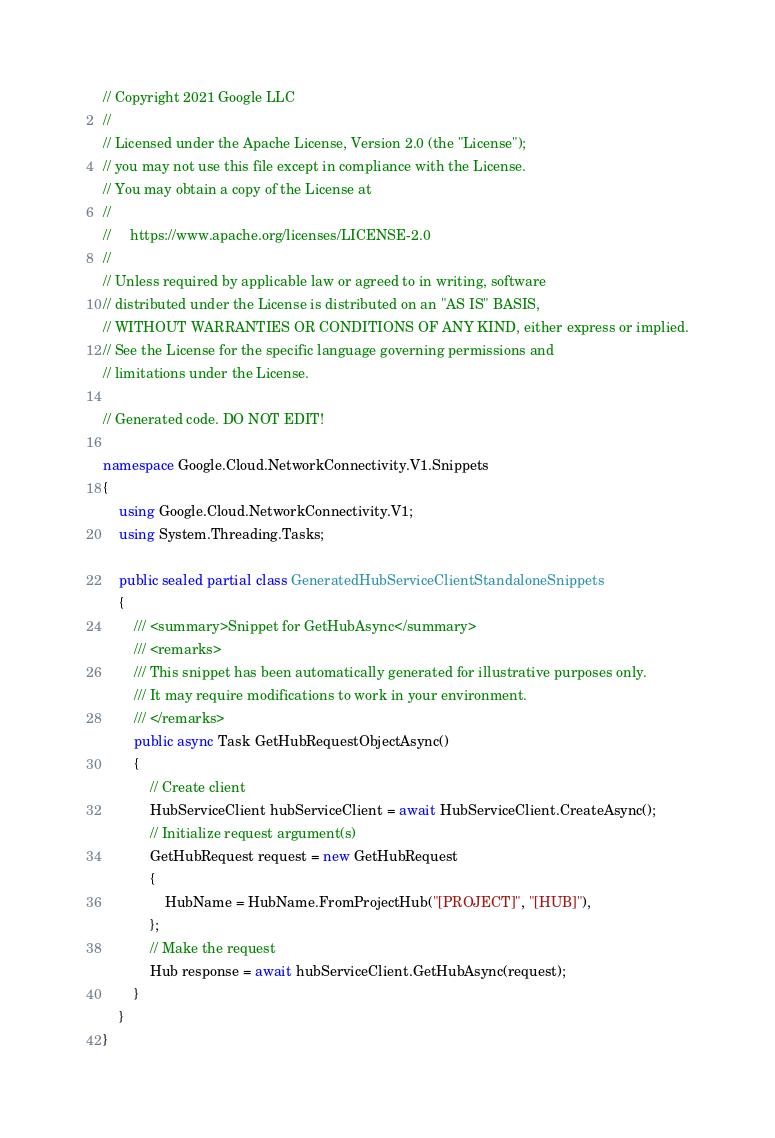Convert code to text. <code><loc_0><loc_0><loc_500><loc_500><_C#_>// Copyright 2021 Google LLC
//
// Licensed under the Apache License, Version 2.0 (the "License");
// you may not use this file except in compliance with the License.
// You may obtain a copy of the License at
//
//     https://www.apache.org/licenses/LICENSE-2.0
//
// Unless required by applicable law or agreed to in writing, software
// distributed under the License is distributed on an "AS IS" BASIS,
// WITHOUT WARRANTIES OR CONDITIONS OF ANY KIND, either express or implied.
// See the License for the specific language governing permissions and
// limitations under the License.

// Generated code. DO NOT EDIT!

namespace Google.Cloud.NetworkConnectivity.V1.Snippets
{
    using Google.Cloud.NetworkConnectivity.V1;
    using System.Threading.Tasks;

    public sealed partial class GeneratedHubServiceClientStandaloneSnippets
    {
        /// <summary>Snippet for GetHubAsync</summary>
        /// <remarks>
        /// This snippet has been automatically generated for illustrative purposes only.
        /// It may require modifications to work in your environment.
        /// </remarks>
        public async Task GetHubRequestObjectAsync()
        {
            // Create client
            HubServiceClient hubServiceClient = await HubServiceClient.CreateAsync();
            // Initialize request argument(s)
            GetHubRequest request = new GetHubRequest
            {
                HubName = HubName.FromProjectHub("[PROJECT]", "[HUB]"),
            };
            // Make the request
            Hub response = await hubServiceClient.GetHubAsync(request);
        }
    }
}
</code> 